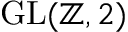Convert formula to latex. <formula><loc_0><loc_0><loc_500><loc_500>{ G L } ( \mathbb { Z } , 2 )</formula> 